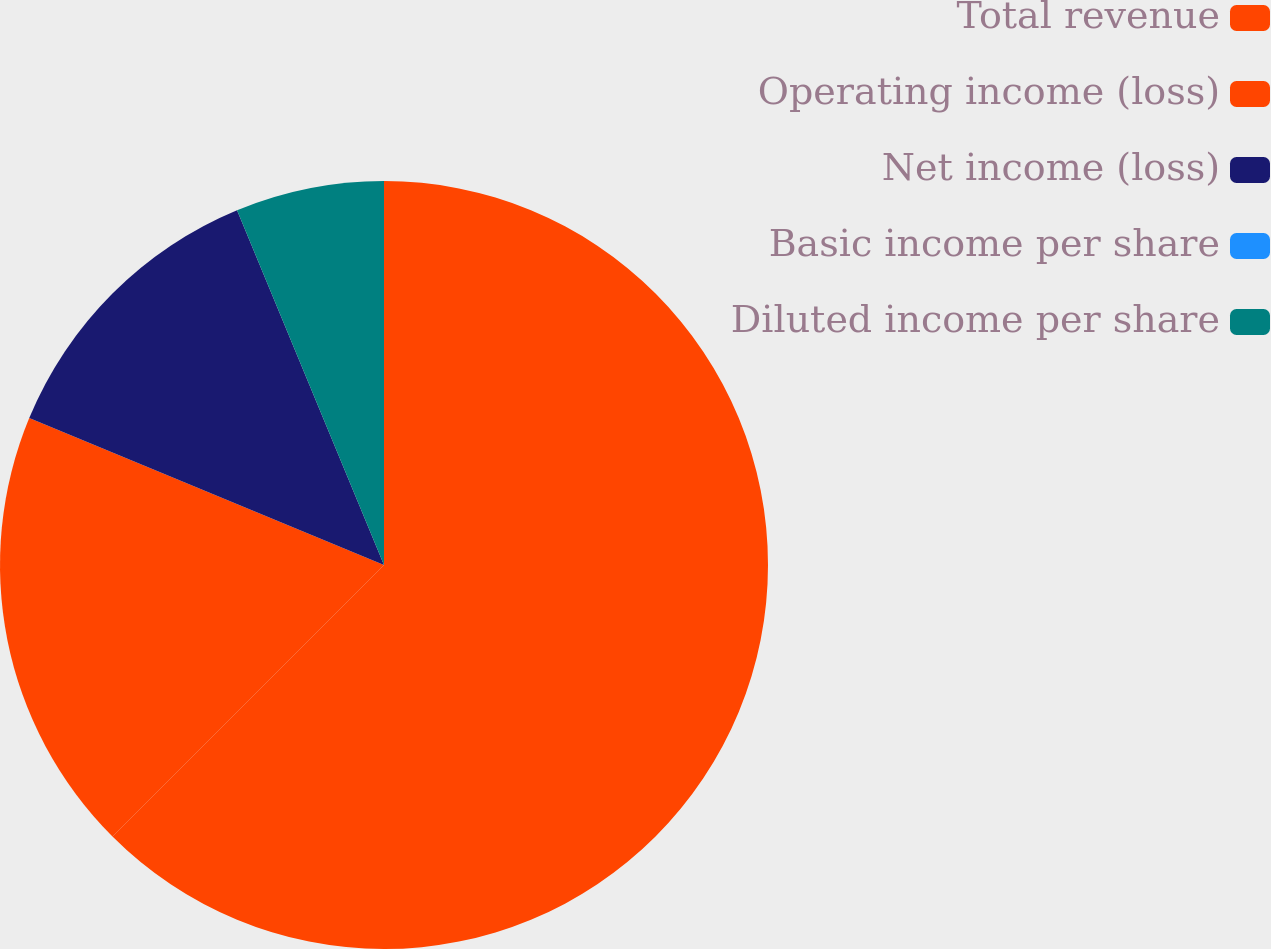Convert chart to OTSL. <chart><loc_0><loc_0><loc_500><loc_500><pie_chart><fcel>Total revenue<fcel>Operating income (loss)<fcel>Net income (loss)<fcel>Basic income per share<fcel>Diluted income per share<nl><fcel>62.5%<fcel>18.75%<fcel>12.5%<fcel>0.0%<fcel>6.25%<nl></chart> 